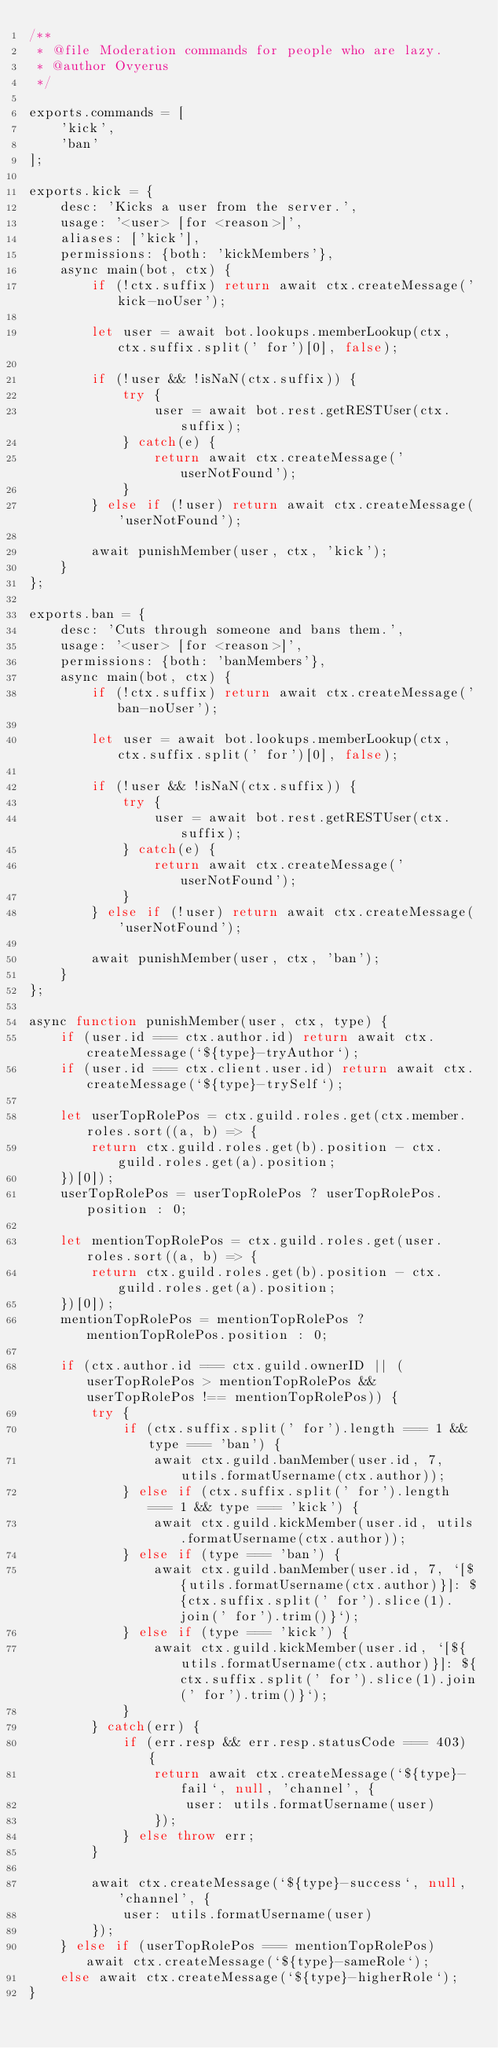Convert code to text. <code><loc_0><loc_0><loc_500><loc_500><_JavaScript_>/**
 * @file Moderation commands for people who are lazy.
 * @author Ovyerus
 */

exports.commands = [
    'kick',
    'ban'
];

exports.kick = {
    desc: 'Kicks a user from the server.',
    usage: '<user> [for <reason>]',
    aliases: ['kick'],
    permissions: {both: 'kickMembers'},
    async main(bot, ctx) {
        if (!ctx.suffix) return await ctx.createMessage('kick-noUser');

        let user = await bot.lookups.memberLookup(ctx, ctx.suffix.split(' for')[0], false);

        if (!user && !isNaN(ctx.suffix)) {
            try {
                user = await bot.rest.getRESTUser(ctx.suffix);
            } catch(e) {
                return await ctx.createMessage('userNotFound');
            }
        } else if (!user) return await ctx.createMessage('userNotFound');

        await punishMember(user, ctx, 'kick');
    }
};

exports.ban = {
    desc: 'Cuts through someone and bans them.',
    usage: '<user> [for <reason>]',
    permissions: {both: 'banMembers'},
    async main(bot, ctx) {
        if (!ctx.suffix) return await ctx.createMessage('ban-noUser');

        let user = await bot.lookups.memberLookup(ctx, ctx.suffix.split(' for')[0], false);

        if (!user && !isNaN(ctx.suffix)) {
            try {
                user = await bot.rest.getRESTUser(ctx.suffix);
            } catch(e) {
                return await ctx.createMessage('userNotFound');
            }
        } else if (!user) return await ctx.createMessage('userNotFound');

        await punishMember(user, ctx, 'ban');
    }
};

async function punishMember(user, ctx, type) {
    if (user.id === ctx.author.id) return await ctx.createMessage(`${type}-tryAuthor`);
    if (user.id === ctx.client.user.id) return await ctx.createMessage(`${type}-trySelf`);

    let userTopRolePos = ctx.guild.roles.get(ctx.member.roles.sort((a, b) => {
        return ctx.guild.roles.get(b).position - ctx.guild.roles.get(a).position;
    })[0]);
    userTopRolePos = userTopRolePos ? userTopRolePos.position : 0;

    let mentionTopRolePos = ctx.guild.roles.get(user.roles.sort((a, b) => {
        return ctx.guild.roles.get(b).position - ctx.guild.roles.get(a).position;
    })[0]);
    mentionTopRolePos = mentionTopRolePos ? mentionTopRolePos.position : 0;

    if (ctx.author.id === ctx.guild.ownerID || (userTopRolePos > mentionTopRolePos && userTopRolePos !== mentionTopRolePos)) {
        try {
            if (ctx.suffix.split(' for').length === 1 && type === 'ban') {
                await ctx.guild.banMember(user.id, 7, utils.formatUsername(ctx.author));
            } else if (ctx.suffix.split(' for').length === 1 && type === 'kick') {
                await ctx.guild.kickMember(user.id, utils.formatUsername(ctx.author));
            } else if (type === 'ban') {
                await ctx.guild.banMember(user.id, 7, `[${utils.formatUsername(ctx.author)}]: ${ctx.suffix.split(' for').slice(1).join(' for').trim()}`);
            } else if (type === 'kick') {
                await ctx.guild.kickMember(user.id, `[${utils.formatUsername(ctx.author)}]: ${ctx.suffix.split(' for').slice(1).join(' for').trim()}`);
            }
        } catch(err) {
            if (err.resp && err.resp.statusCode === 403) {
                return await ctx.createMessage(`${type}-fail`, null, 'channel', {
                    user: utils.formatUsername(user)
                });
            } else throw err;
        }

        await ctx.createMessage(`${type}-success`, null, 'channel', {
            user: utils.formatUsername(user)
        });
    } else if (userTopRolePos === mentionTopRolePos) await ctx.createMessage(`${type}-sameRole`);
    else await ctx.createMessage(`${type}-higherRole`);
}</code> 